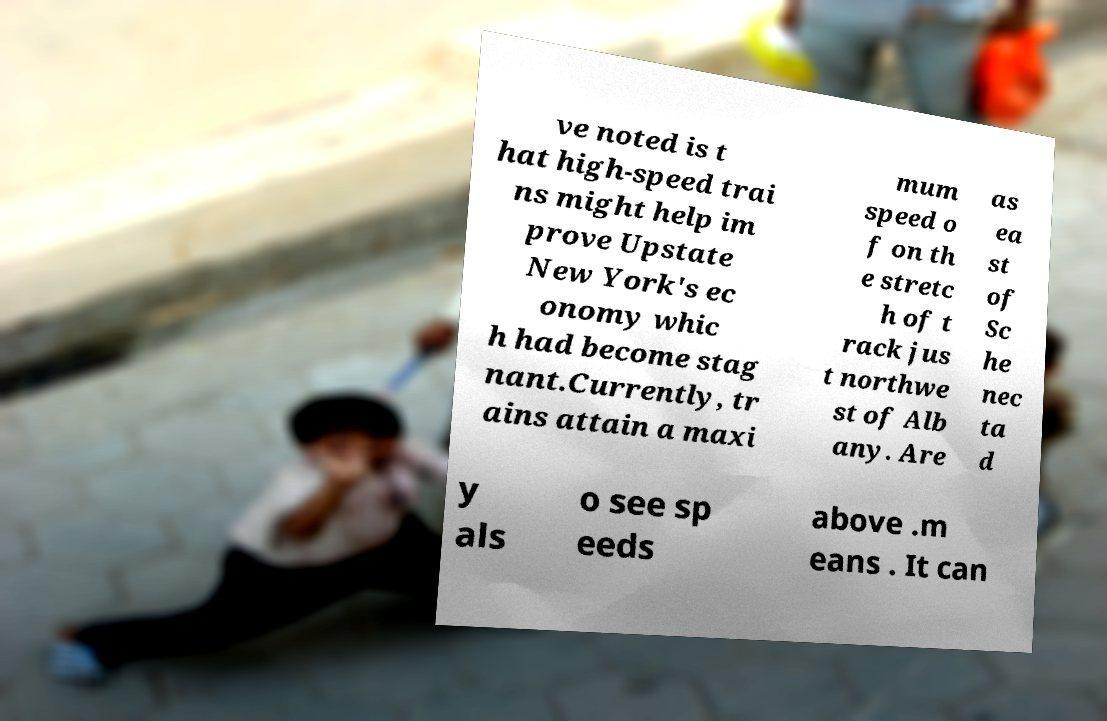What messages or text are displayed in this image? I need them in a readable, typed format. ve noted is t hat high-speed trai ns might help im prove Upstate New York's ec onomy whic h had become stag nant.Currently, tr ains attain a maxi mum speed o f on th e stretc h of t rack jus t northwe st of Alb any. Are as ea st of Sc he nec ta d y als o see sp eeds above .m eans . It can 